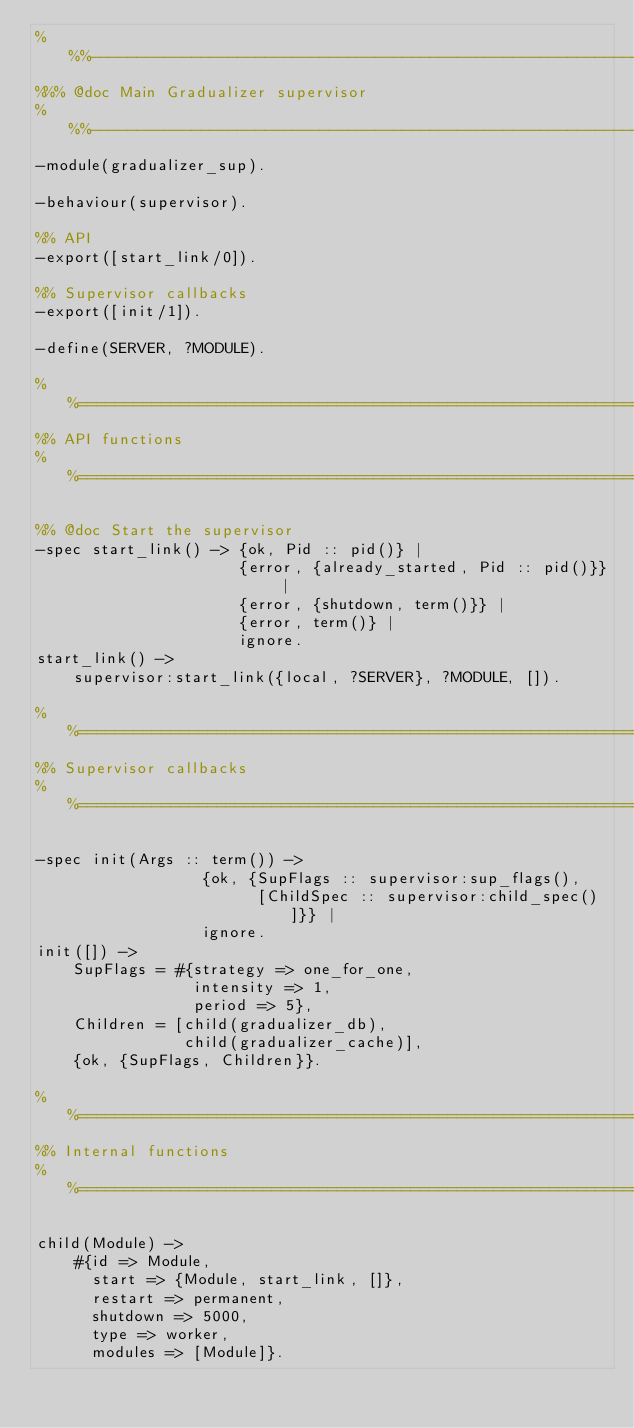<code> <loc_0><loc_0><loc_500><loc_500><_Erlang_>%%%-------------------------------------------------------------------
%%% @doc Main Gradualizer supervisor
%%%-------------------------------------------------------------------
-module(gradualizer_sup).

-behaviour(supervisor).

%% API
-export([start_link/0]).

%% Supervisor callbacks
-export([init/1]).

-define(SERVER, ?MODULE).

%%===================================================================
%% API functions
%%===================================================================

%% @doc Start the supervisor
-spec start_link() -> {ok, Pid :: pid()} |
                      {error, {already_started, Pid :: pid()}} |
                      {error, {shutdown, term()}} |
                      {error, term()} |
                      ignore.
start_link() ->
    supervisor:start_link({local, ?SERVER}, ?MODULE, []).

%%===================================================================
%% Supervisor callbacks
%%===================================================================

-spec init(Args :: term()) ->
                  {ok, {SupFlags :: supervisor:sup_flags(),
                        [ChildSpec :: supervisor:child_spec()]}} |
                  ignore.
init([]) ->
    SupFlags = #{strategy => one_for_one,
                 intensity => 1,
                 period => 5},
    Children = [child(gradualizer_db),
                child(gradualizer_cache)],
    {ok, {SupFlags, Children}}.

%%===================================================================
%% Internal functions
%%===================================================================

child(Module) ->
    #{id => Module,
      start => {Module, start_link, []},
      restart => permanent,
      shutdown => 5000,
      type => worker,
      modules => [Module]}.

    
</code> 